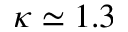<formula> <loc_0><loc_0><loc_500><loc_500>\kappa \simeq 1 . 3</formula> 